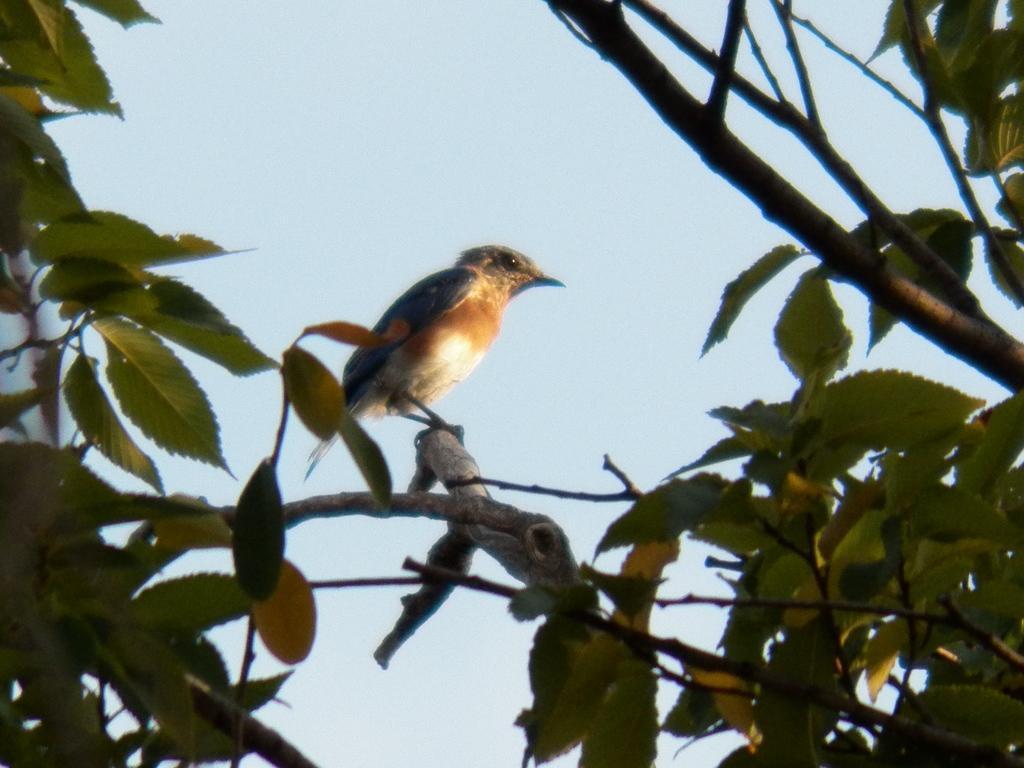Can you describe this image briefly? In this image we can see a bird on the stem of a tree. In the background there is sky. 